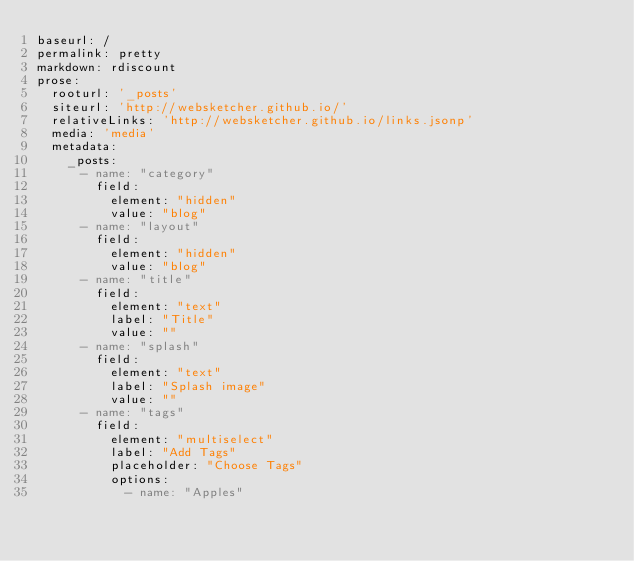Convert code to text. <code><loc_0><loc_0><loc_500><loc_500><_YAML_>baseurl: /
permalink: pretty
markdown: rdiscount
prose:
  rooturl: '_posts'
  siteurl: 'http://websketcher.github.io/'
  relativeLinks: 'http://websketcher.github.io/links.jsonp'
  media: 'media'
  metadata:
    _posts:
      - name: "category"
        field:
          element: "hidden"
          value: "blog"
      - name: "layout"
        field:
          element: "hidden"
          value: "blog"
      - name: "title"
        field:
          element: "text"
          label: "Title"
          value: ""
      - name: "splash"
        field:
          element: "text"
          label: "Splash image"
          value: ""
      - name: "tags"
        field:
          element: "multiselect"
          label: "Add Tags"
          placeholder: "Choose Tags"
          options:
            - name: "Apples"</code> 